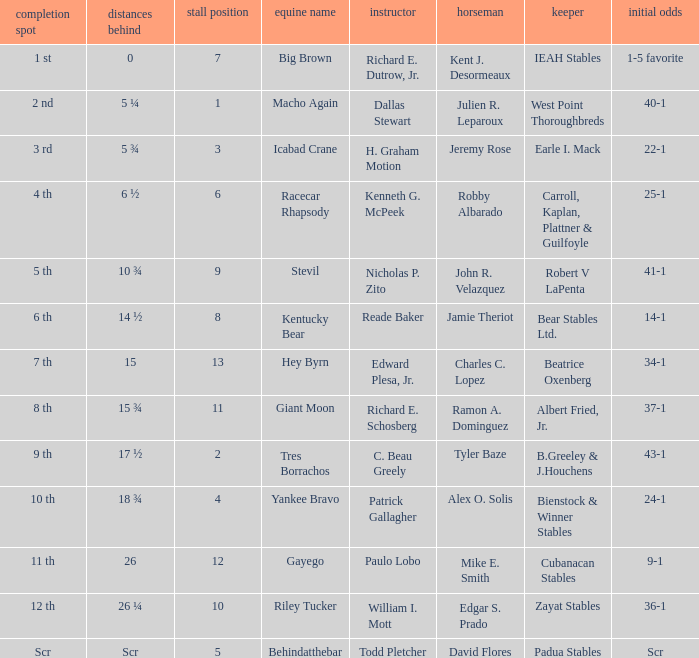Who was the rider with starting odds of 34-1? Charles C. Lopez. 